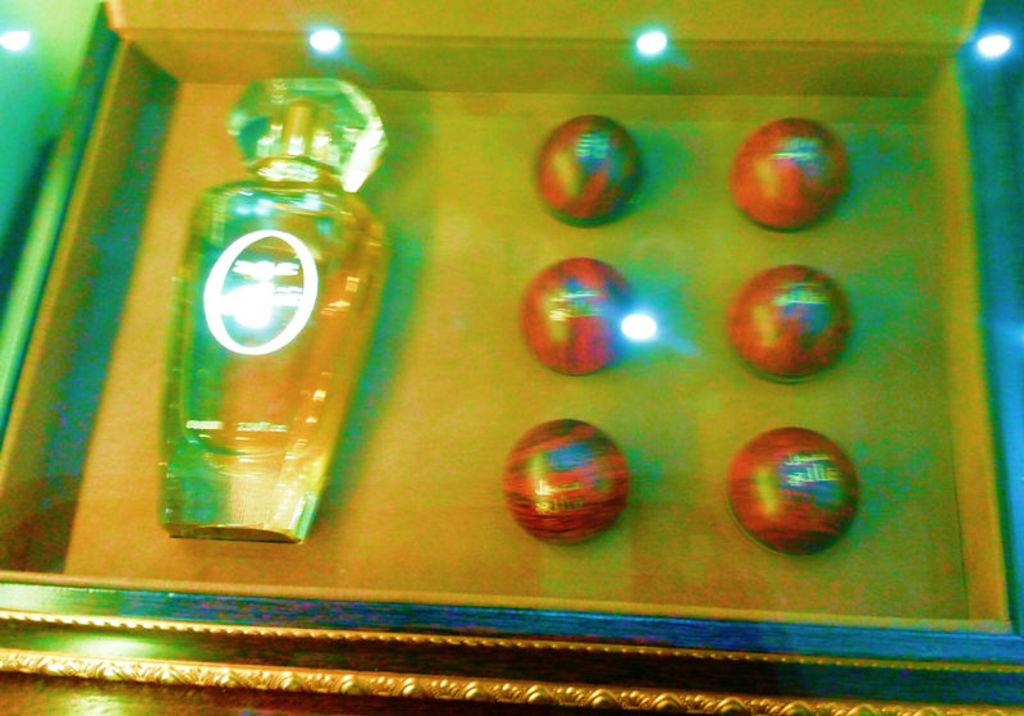What is the main object in the image? There is a box in the image. What items are inside the box? There are six balls and a bottle in the box. Where is the lunchroom located in the image? There is no lunchroom present in the image. How many cats can be seen interacting with the balls in the image? There are no cats present in the image. 